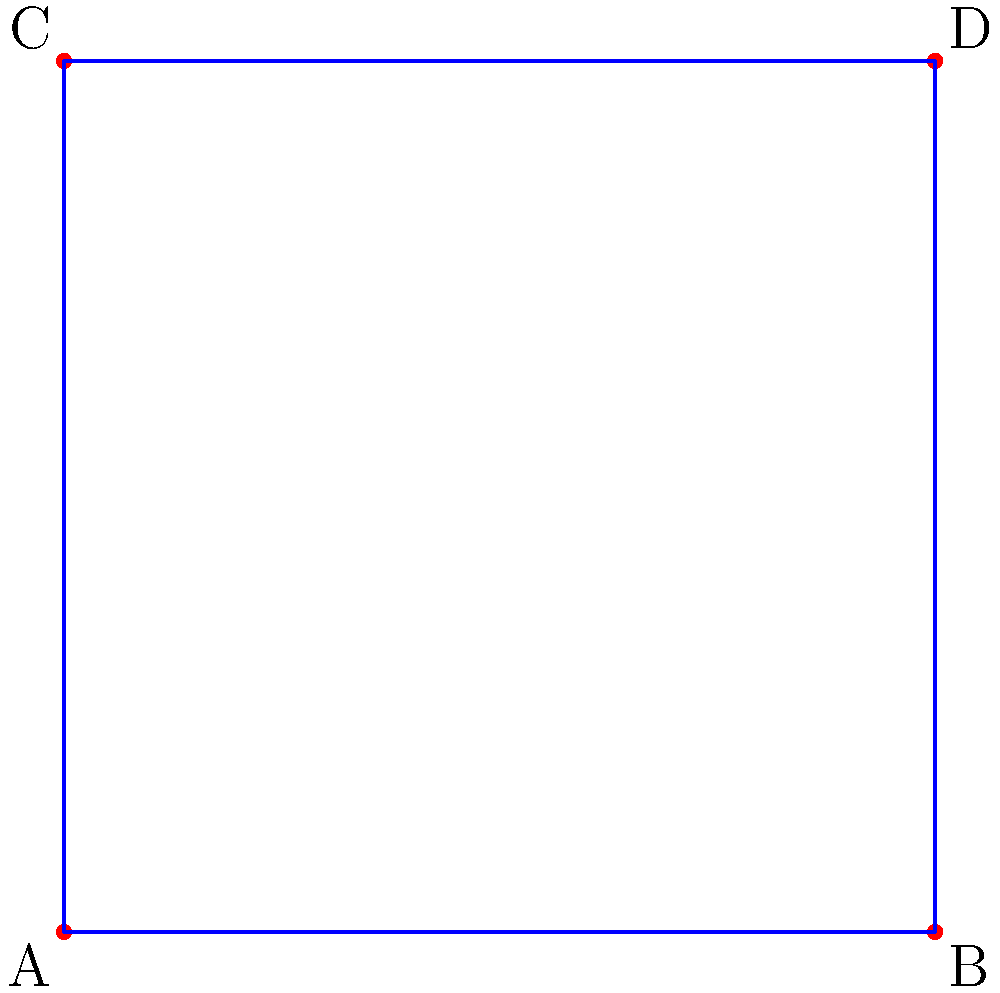A fun puzzle game involves connecting dots to form different shapes. In the image above, four dots are connected to form a square. If you were to count all the possible ways to connect these four dots to form different shapes (including lines, triangles, and the square), how many unique shapes could you make? Let's break this down step-by-step:

1. First, let's count the number of possible line segments:
   - AB, BC, CD, DA (sides of the square)
   - AC, BD (diagonals)
   Total: 6 line segments

2. Now, let's count the shapes:
   - Individual line segments: 6 (AB, BC, CD, DA, AC, BD)
   - Triangles:
     * ABC, BCD, CDA, DAB (using three sides of the square)
     * ACD, ABD (using two sides and a diagonal)
     Total triangles: 6
   - Square: 1 (ABCD)

3. Adding up all the shapes:
   6 (lines) + 6 (triangles) + 1 (square) = 13 unique shapes

Therefore, you can form 13 different shapes by connecting these four dots in various ways.
Answer: 13 shapes 